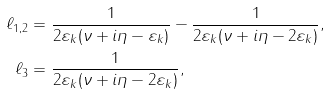Convert formula to latex. <formula><loc_0><loc_0><loc_500><loc_500>\ell _ { 1 , 2 } & = \frac { 1 } { 2 \varepsilon _ { k } ( \nu + i \eta - \varepsilon _ { k } ) } - \frac { 1 } { 2 \varepsilon _ { k } ( \nu + i \eta - 2 \varepsilon _ { k } ) } , \\ \ell _ { 3 } & = \frac { 1 } { 2 \varepsilon _ { k } ( \nu + i \eta - 2 \varepsilon _ { k } ) } ,</formula> 